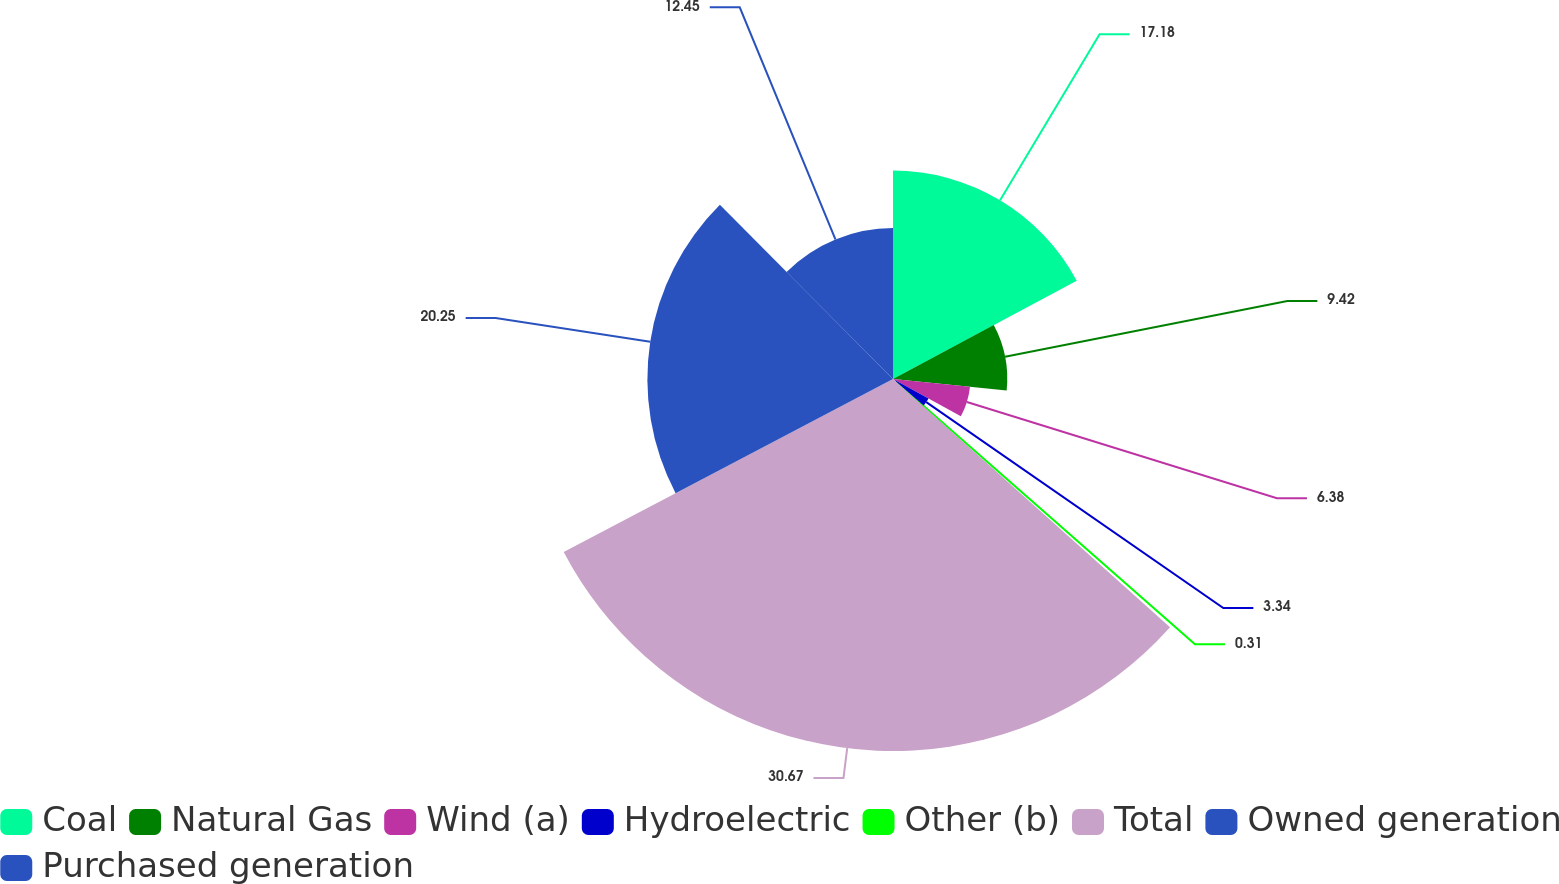<chart> <loc_0><loc_0><loc_500><loc_500><pie_chart><fcel>Coal<fcel>Natural Gas<fcel>Wind (a)<fcel>Hydroelectric<fcel>Other (b)<fcel>Total<fcel>Owned generation<fcel>Purchased generation<nl><fcel>17.18%<fcel>9.42%<fcel>6.38%<fcel>3.34%<fcel>0.31%<fcel>30.67%<fcel>20.25%<fcel>12.45%<nl></chart> 